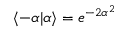<formula> <loc_0><loc_0><loc_500><loc_500>\langle - \alpha | \alpha \rangle = e ^ { - 2 \alpha ^ { 2 } }</formula> 